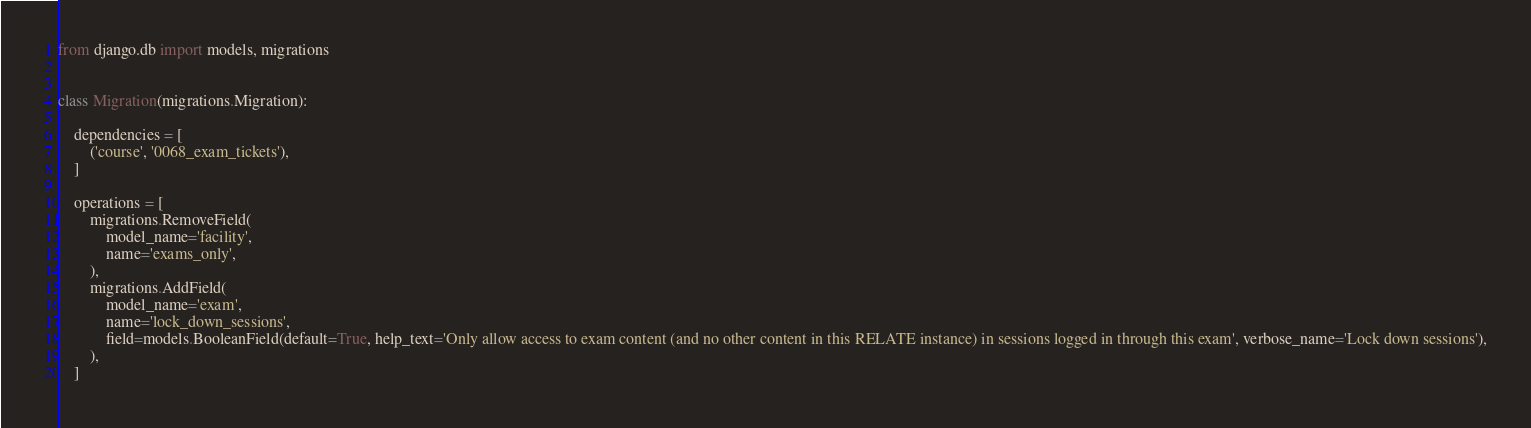<code> <loc_0><loc_0><loc_500><loc_500><_Python_>from django.db import models, migrations


class Migration(migrations.Migration):

    dependencies = [
        ('course', '0068_exam_tickets'),
    ]

    operations = [
        migrations.RemoveField(
            model_name='facility',
            name='exams_only',
        ),
        migrations.AddField(
            model_name='exam',
            name='lock_down_sessions',
            field=models.BooleanField(default=True, help_text='Only allow access to exam content (and no other content in this RELATE instance) in sessions logged in through this exam', verbose_name='Lock down sessions'),
        ),
    ]
</code> 